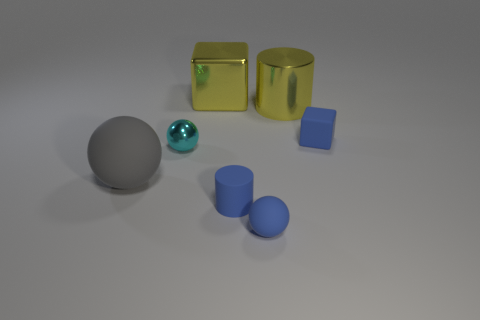Subtract all metal balls. How many balls are left? 2 Add 1 gray matte balls. How many objects exist? 8 Subtract all brown spheres. Subtract all purple cylinders. How many spheres are left? 3 Subtract all cylinders. How many objects are left? 5 Subtract all big gray spheres. Subtract all big metal cylinders. How many objects are left? 5 Add 1 small cyan balls. How many small cyan balls are left? 2 Add 6 small green metallic things. How many small green metallic things exist? 6 Subtract 0 brown blocks. How many objects are left? 7 